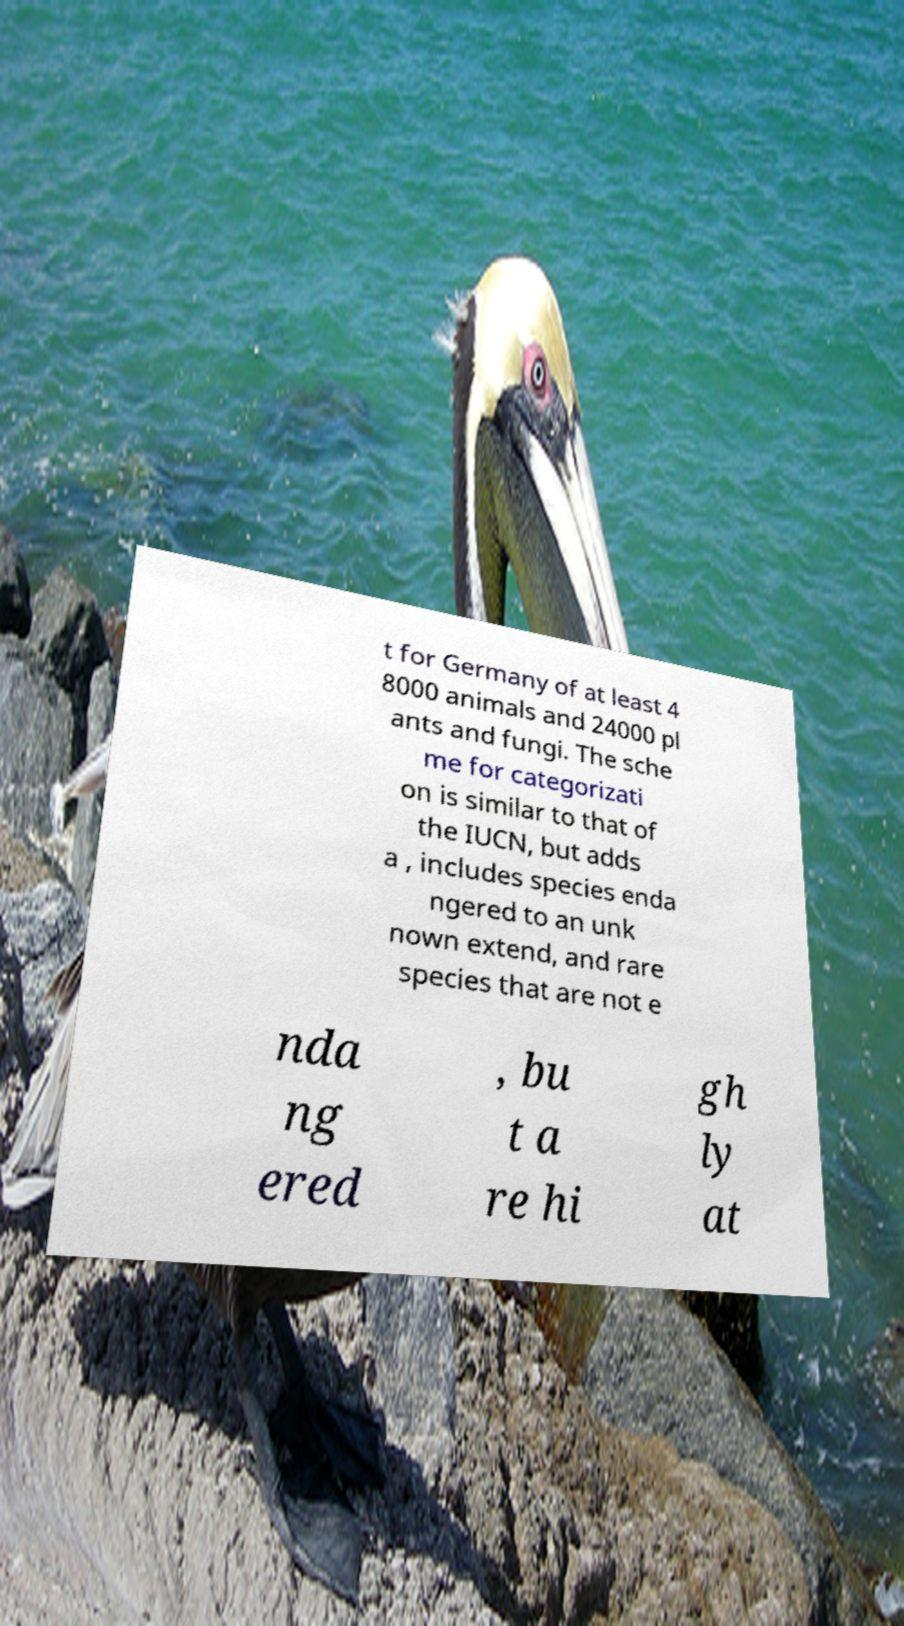Can you accurately transcribe the text from the provided image for me? t for Germany of at least 4 8000 animals and 24000 pl ants and fungi. The sche me for categorizati on is similar to that of the IUCN, but adds a , includes species enda ngered to an unk nown extend, and rare species that are not e nda ng ered , bu t a re hi gh ly at 